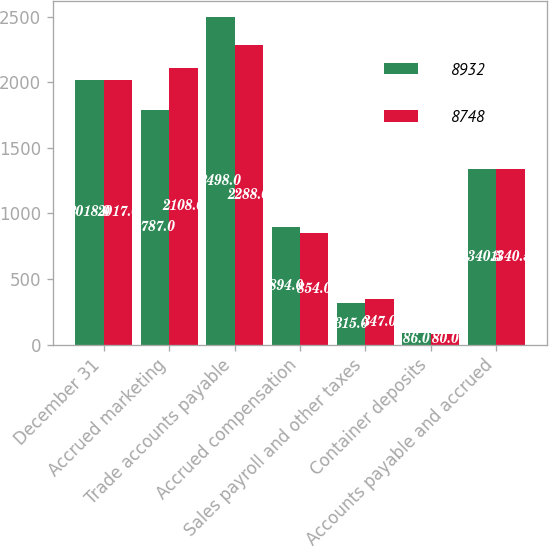Convert chart. <chart><loc_0><loc_0><loc_500><loc_500><stacked_bar_chart><ecel><fcel>December 31<fcel>Accrued marketing<fcel>Trade accounts payable<fcel>Accrued compensation<fcel>Sales payroll and other taxes<fcel>Container deposits<fcel>Accounts payable and accrued<nl><fcel>8932<fcel>2018<fcel>1787<fcel>2498<fcel>894<fcel>315<fcel>86<fcel>1340.5<nl><fcel>8748<fcel>2017<fcel>2108<fcel>2288<fcel>854<fcel>347<fcel>80<fcel>1340.5<nl></chart> 